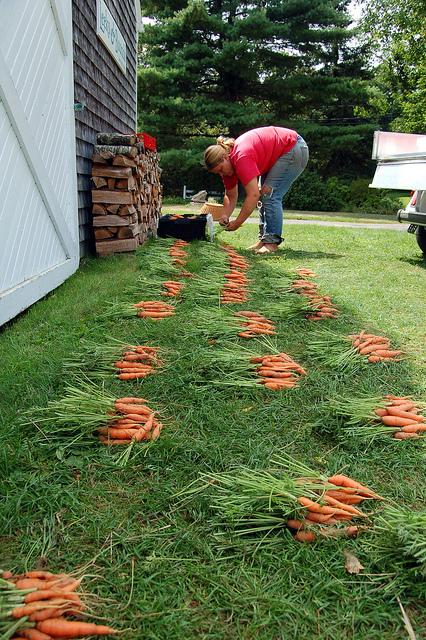What is she picking?
Answer briefly. Carrots. What color is the woman's shirt?
Quick response, please. Red. Why are the carrots on the ground?
Be succinct. Harvesting. 